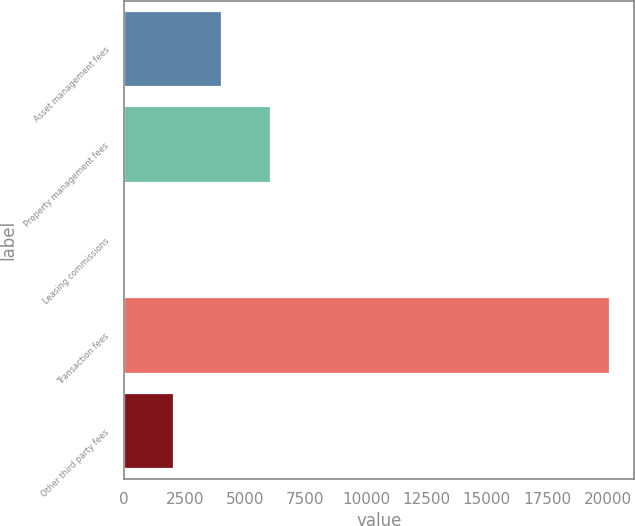Convert chart to OTSL. <chart><loc_0><loc_0><loc_500><loc_500><bar_chart><fcel>Asset management fees<fcel>Property management fees<fcel>Leasing commissions<fcel>Transaction fees<fcel>Other third party fees<nl><fcel>4055.2<fcel>6060.8<fcel>44<fcel>20100<fcel>2049.6<nl></chart> 